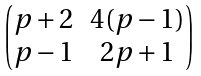Convert formula to latex. <formula><loc_0><loc_0><loc_500><loc_500>\begin{pmatrix} p + 2 & 4 ( p - 1 ) \\ p - 1 & 2 p + 1 \\ \end{pmatrix}</formula> 